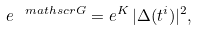<formula> <loc_0><loc_0><loc_500><loc_500>e ^ { \ m a t h s c r { G } } = e ^ { K } \, | \Delta ( t ^ { i } ) | ^ { 2 } ,</formula> 